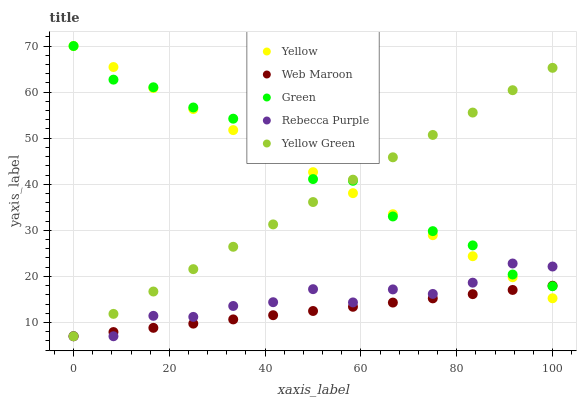Does Web Maroon have the minimum area under the curve?
Answer yes or no. Yes. Does Green have the maximum area under the curve?
Answer yes or no. Yes. Does Rebecca Purple have the minimum area under the curve?
Answer yes or no. No. Does Rebecca Purple have the maximum area under the curve?
Answer yes or no. No. Is Web Maroon the smoothest?
Answer yes or no. Yes. Is Rebecca Purple the roughest?
Answer yes or no. Yes. Is Rebecca Purple the smoothest?
Answer yes or no. No. Is Web Maroon the roughest?
Answer yes or no. No. Does Web Maroon have the lowest value?
Answer yes or no. Yes. Does Yellow have the lowest value?
Answer yes or no. No. Does Yellow have the highest value?
Answer yes or no. Yes. Does Rebecca Purple have the highest value?
Answer yes or no. No. Does Rebecca Purple intersect Yellow?
Answer yes or no. Yes. Is Rebecca Purple less than Yellow?
Answer yes or no. No. Is Rebecca Purple greater than Yellow?
Answer yes or no. No. 